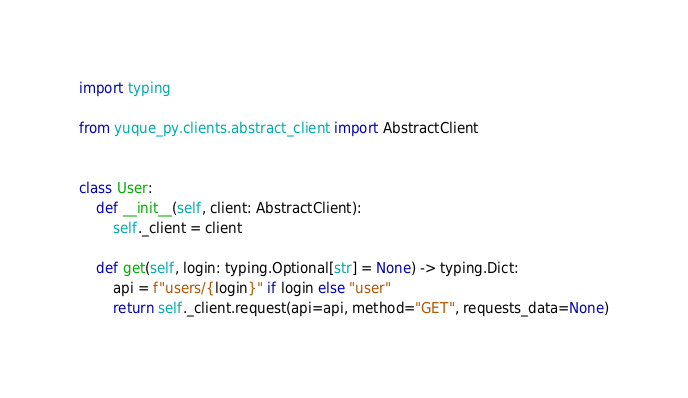Convert code to text. <code><loc_0><loc_0><loc_500><loc_500><_Python_>import typing

from yuque_py.clients.abstract_client import AbstractClient


class User:
    def __init__(self, client: AbstractClient):
        self._client = client

    def get(self, login: typing.Optional[str] = None) -> typing.Dict:
        api = f"users/{login}" if login else "user"
        return self._client.request(api=api, method="GET", requests_data=None)
</code> 